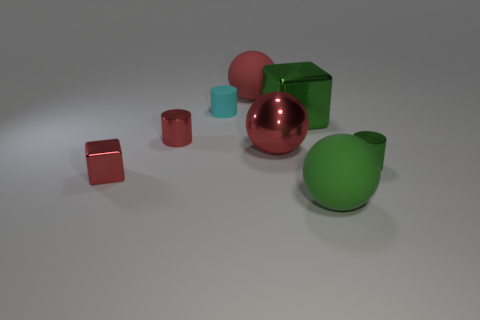Subtract all gray cylinders. How many red spheres are left? 2 Subtract all big red metal balls. How many balls are left? 2 Add 1 green rubber spheres. How many objects exist? 9 Subtract 0 brown cylinders. How many objects are left? 8 Subtract all cubes. How many objects are left? 6 Subtract 1 balls. How many balls are left? 2 Subtract all gray cylinders. Subtract all gray spheres. How many cylinders are left? 3 Subtract all green matte cubes. Subtract all red rubber spheres. How many objects are left? 7 Add 5 cyan cylinders. How many cyan cylinders are left? 6 Add 8 large blue cylinders. How many large blue cylinders exist? 8 